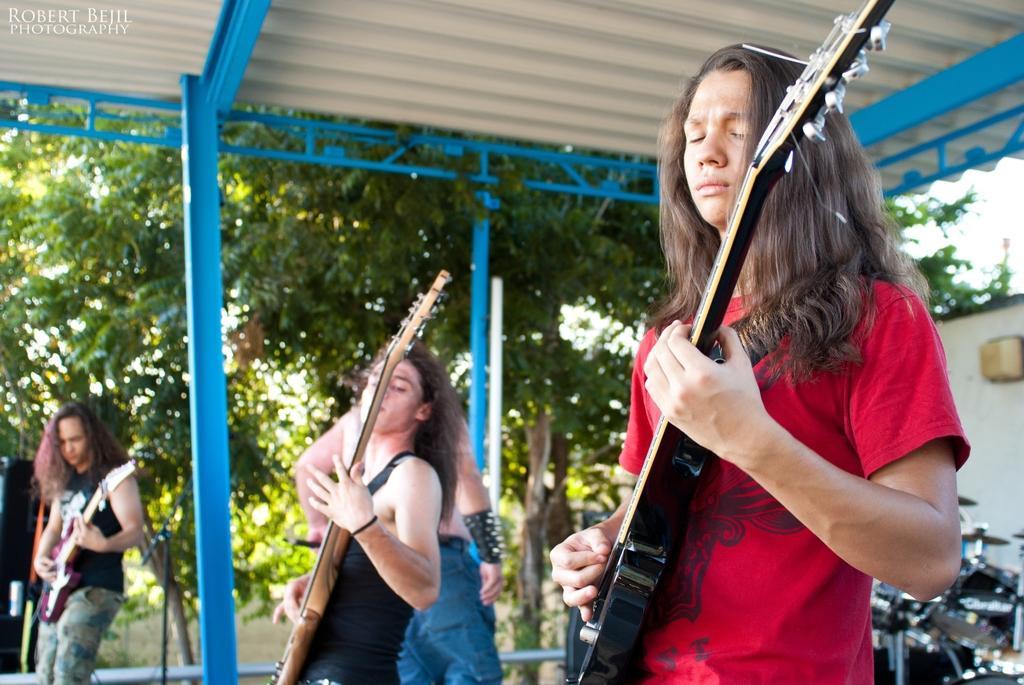Could you give a brief overview of what you see in this image? In this image, we can see few people. Three people are playing a guitar. Background we can see a musical instrument, pillar, trees, shed. Top left corner, we can see a watermark in the image. 